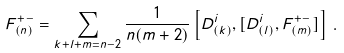Convert formula to latex. <formula><loc_0><loc_0><loc_500><loc_500>F ^ { + - } _ { ( n ) } = \sum _ { k + l + m = n - 2 } \frac { 1 } { n ( m + 2 ) } \left [ D ^ { i } _ { ( k ) } , [ D ^ { i } _ { ( l ) } , F ^ { + - } _ { ( m ) } ] \right ] \, .</formula> 